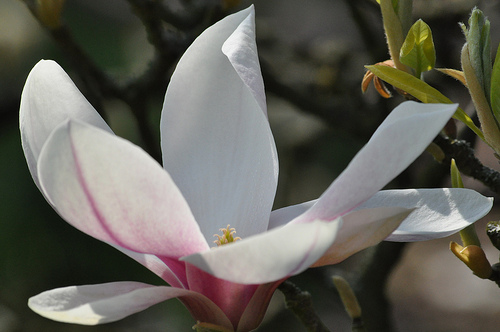<image>
Can you confirm if the sunflower white is under the honey bud? No. The sunflower white is not positioned under the honey bud. The vertical relationship between these objects is different. 